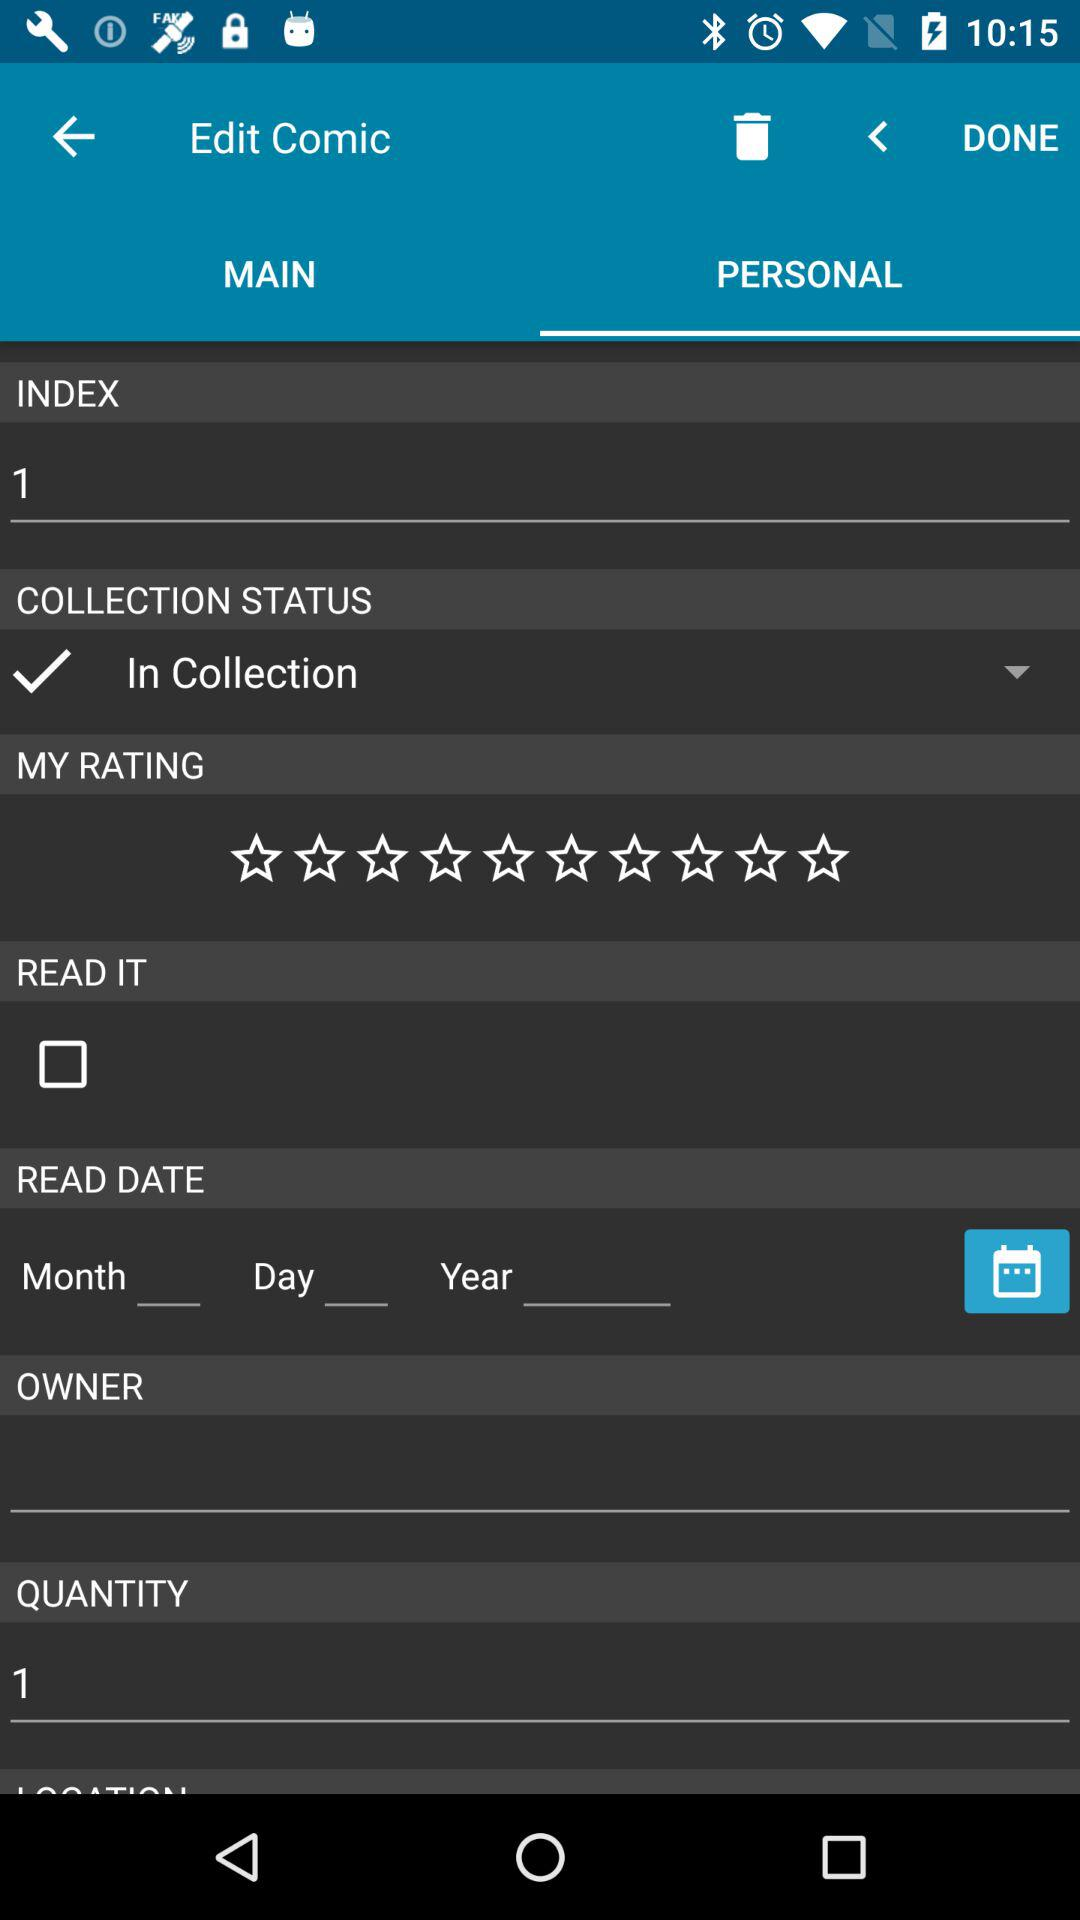Which tab is open? The selected tab is "PERSONAL". 